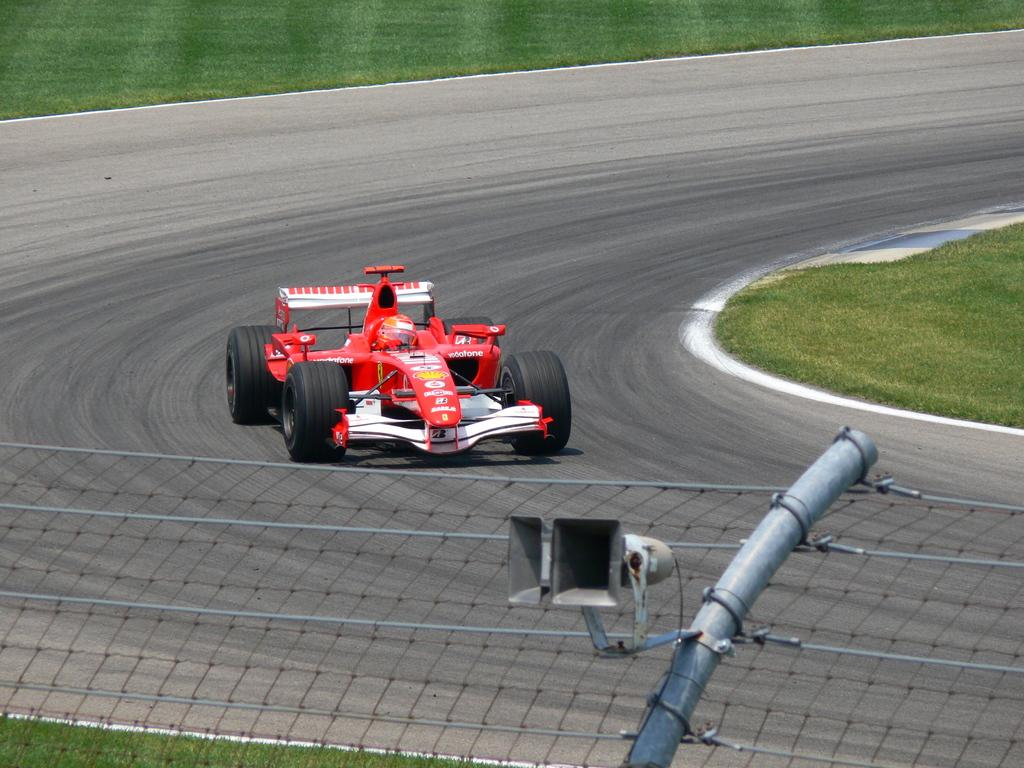What is on the road in the image? There is a vehicle on the road in the image. What type of vegetation can be seen in the image? There is grass visible in the image. What kind of material is present in the image? There is a mesh in the image. What type of sweater is the vehicle wearing in the image? There is no sweater present in the image, and vehicles do not wear clothing. 